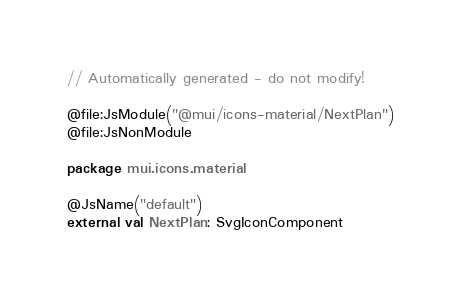Convert code to text. <code><loc_0><loc_0><loc_500><loc_500><_Kotlin_>// Automatically generated - do not modify!

@file:JsModule("@mui/icons-material/NextPlan")
@file:JsNonModule

package mui.icons.material

@JsName("default")
external val NextPlan: SvgIconComponent
</code> 